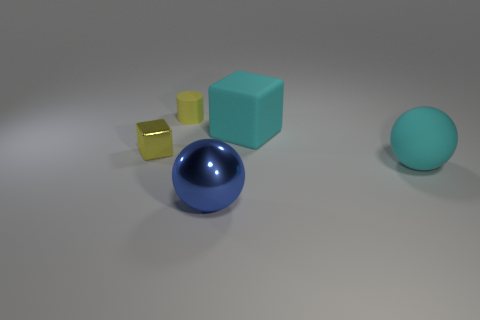Add 3 tiny yellow rubber cylinders. How many objects exist? 8 Subtract all cylinders. How many objects are left? 4 Subtract all balls. Subtract all large cyan rubber objects. How many objects are left? 1 Add 4 matte blocks. How many matte blocks are left? 5 Add 4 cylinders. How many cylinders exist? 5 Subtract 0 yellow balls. How many objects are left? 5 